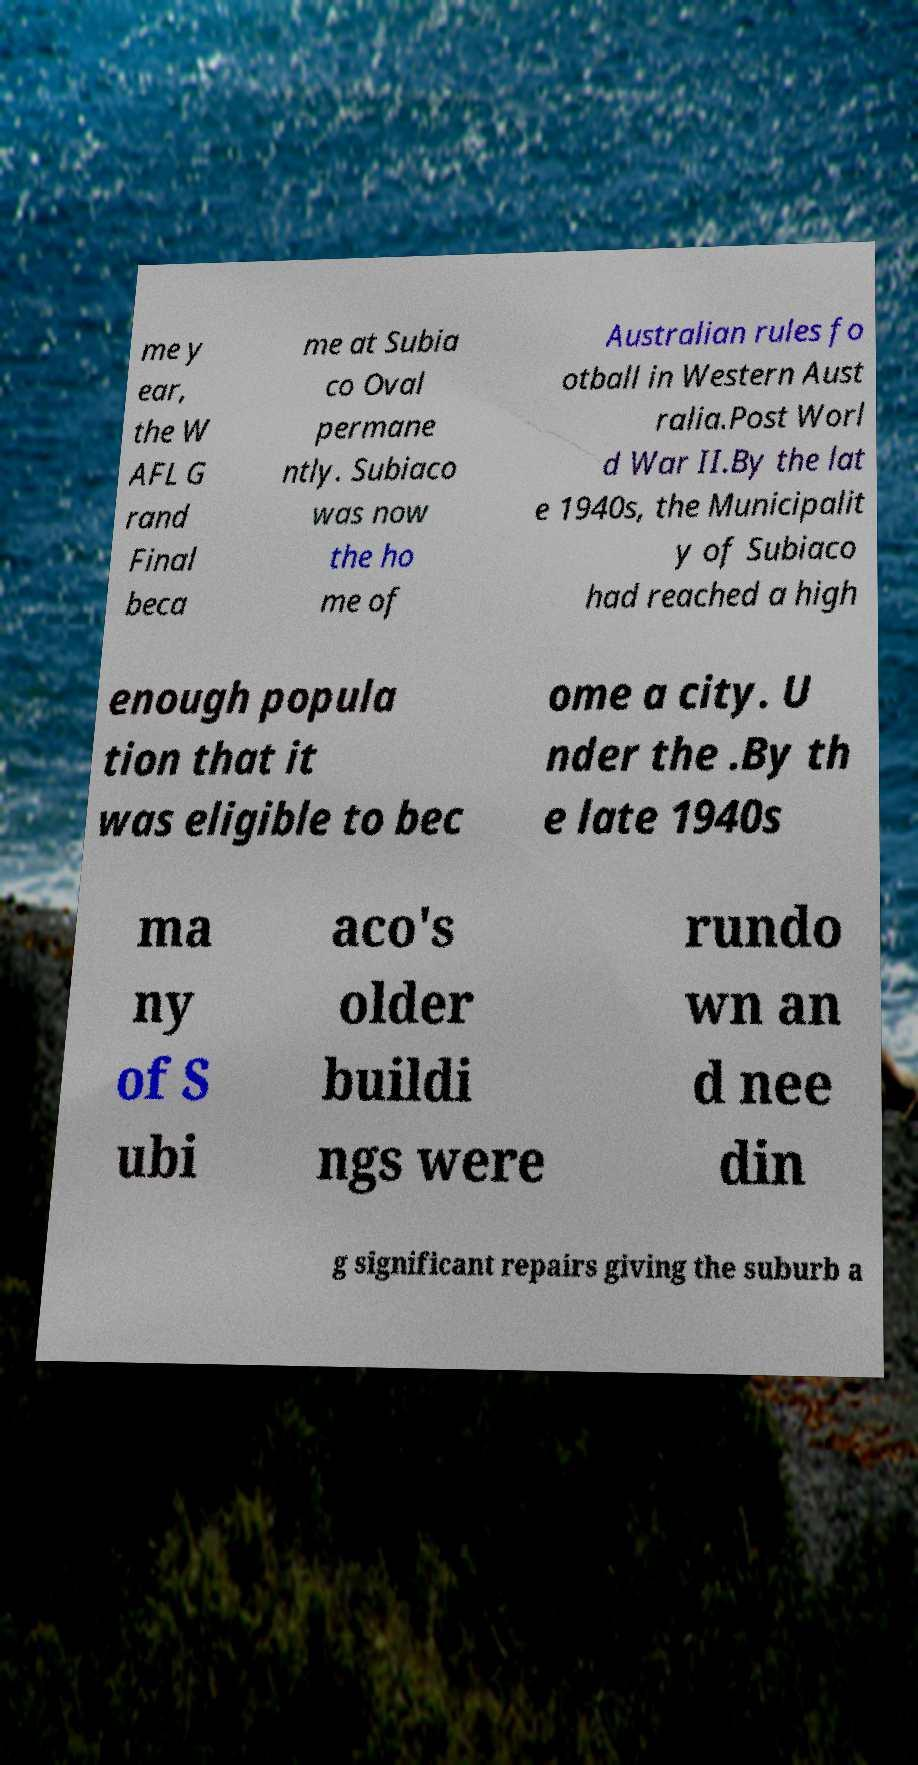Can you accurately transcribe the text from the provided image for me? me y ear, the W AFL G rand Final beca me at Subia co Oval permane ntly. Subiaco was now the ho me of Australian rules fo otball in Western Aust ralia.Post Worl d War II.By the lat e 1940s, the Municipalit y of Subiaco had reached a high enough popula tion that it was eligible to bec ome a city. U nder the .By th e late 1940s ma ny of S ubi aco's older buildi ngs were rundo wn an d nee din g significant repairs giving the suburb a 